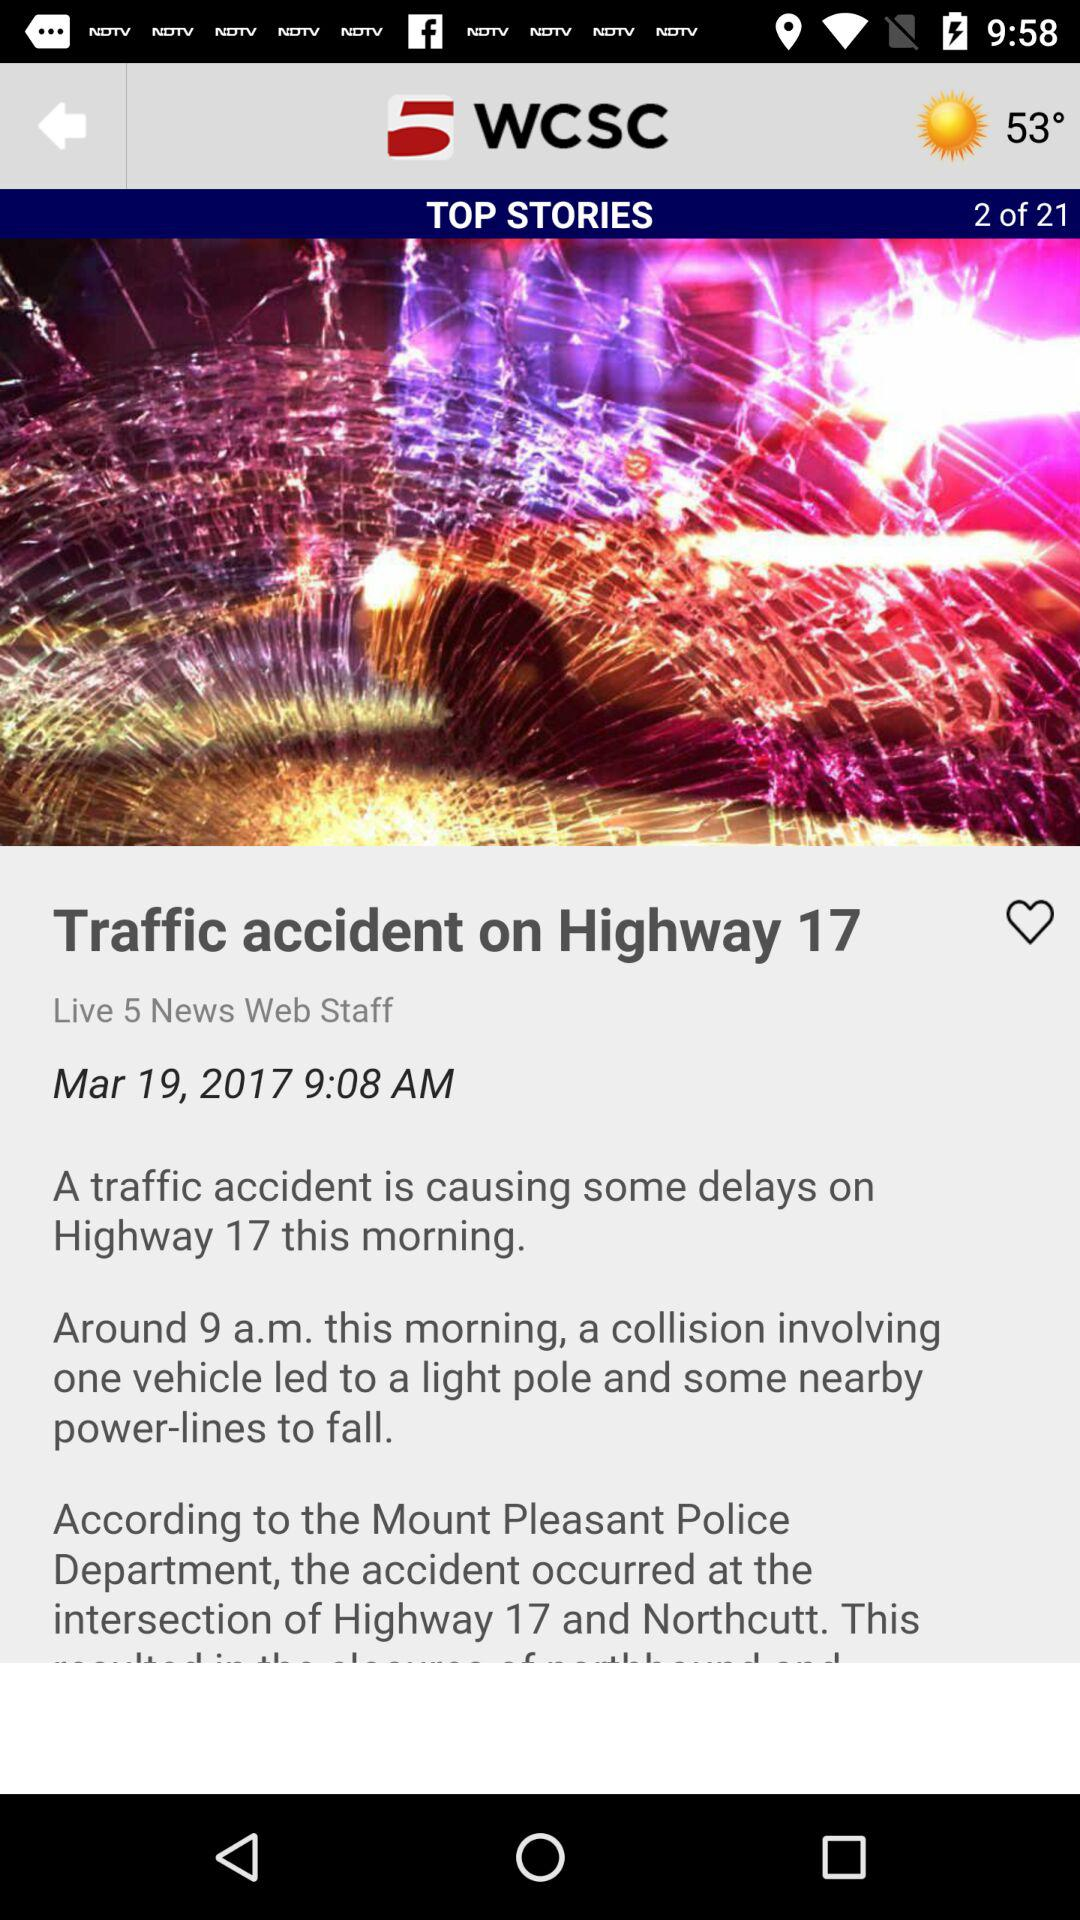What is the application name? The application name is "WCSC". 